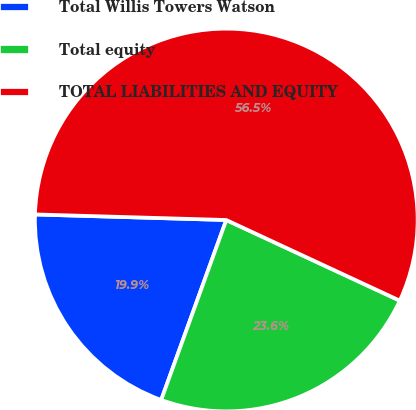Convert chart to OTSL. <chart><loc_0><loc_0><loc_500><loc_500><pie_chart><fcel>Total Willis Towers Watson<fcel>Total equity<fcel>TOTAL LIABILITIES AND EQUITY<nl><fcel>19.94%<fcel>23.6%<fcel>56.46%<nl></chart> 